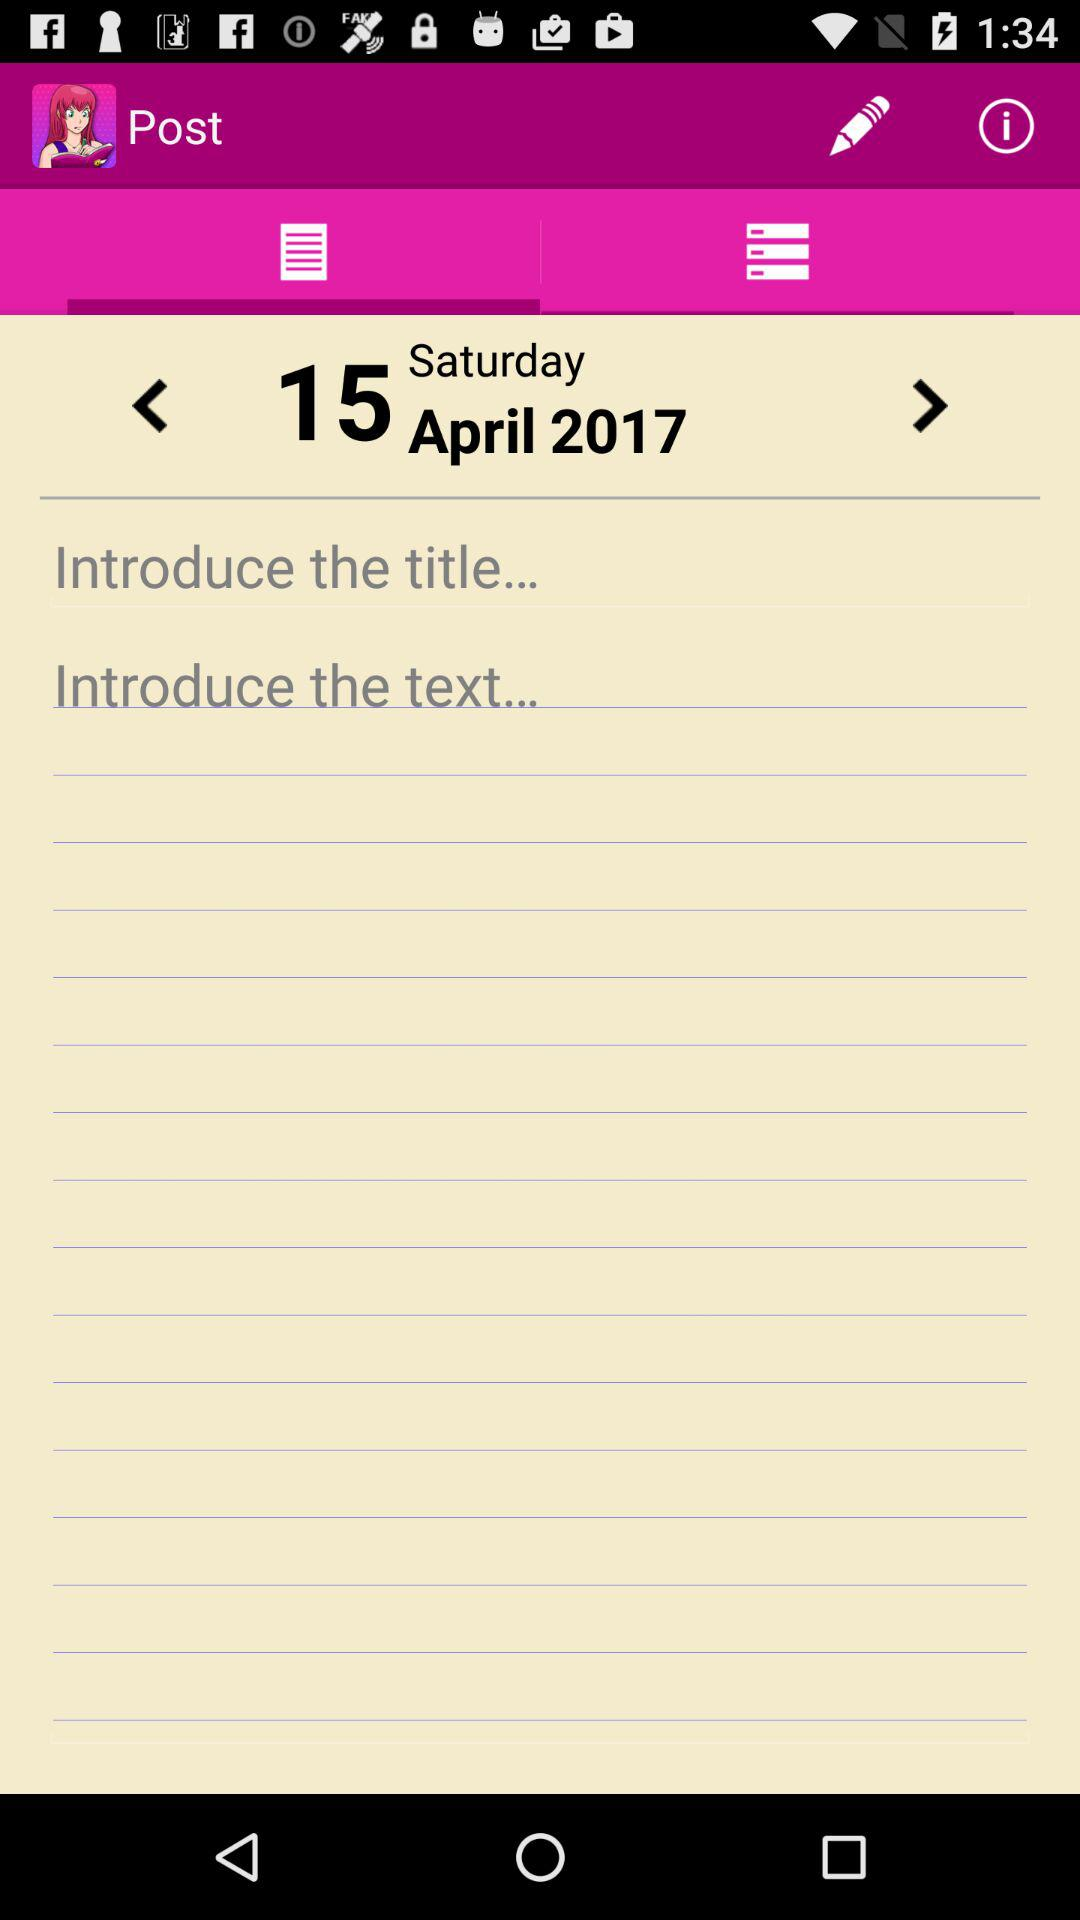What is the selected date? The selected date is Saturday, April 15, 2017. 